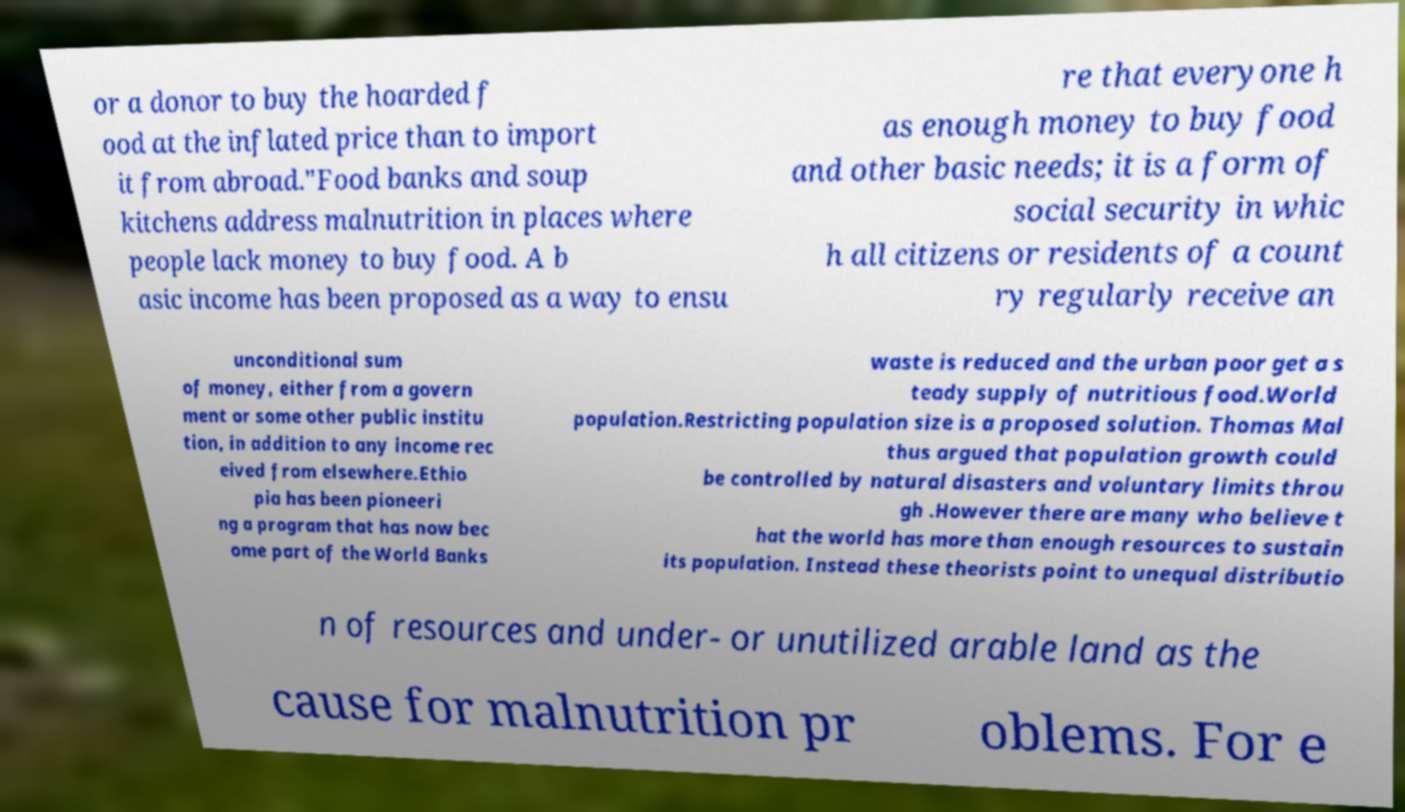What messages or text are displayed in this image? I need them in a readable, typed format. or a donor to buy the hoarded f ood at the inflated price than to import it from abroad."Food banks and soup kitchens address malnutrition in places where people lack money to buy food. A b asic income has been proposed as a way to ensu re that everyone h as enough money to buy food and other basic needs; it is a form of social security in whic h all citizens or residents of a count ry regularly receive an unconditional sum of money, either from a govern ment or some other public institu tion, in addition to any income rec eived from elsewhere.Ethio pia has been pioneeri ng a program that has now bec ome part of the World Banks waste is reduced and the urban poor get a s teady supply of nutritious food.World population.Restricting population size is a proposed solution. Thomas Mal thus argued that population growth could be controlled by natural disasters and voluntary limits throu gh .However there are many who believe t hat the world has more than enough resources to sustain its population. Instead these theorists point to unequal distributio n of resources and under- or unutilized arable land as the cause for malnutrition pr oblems. For e 